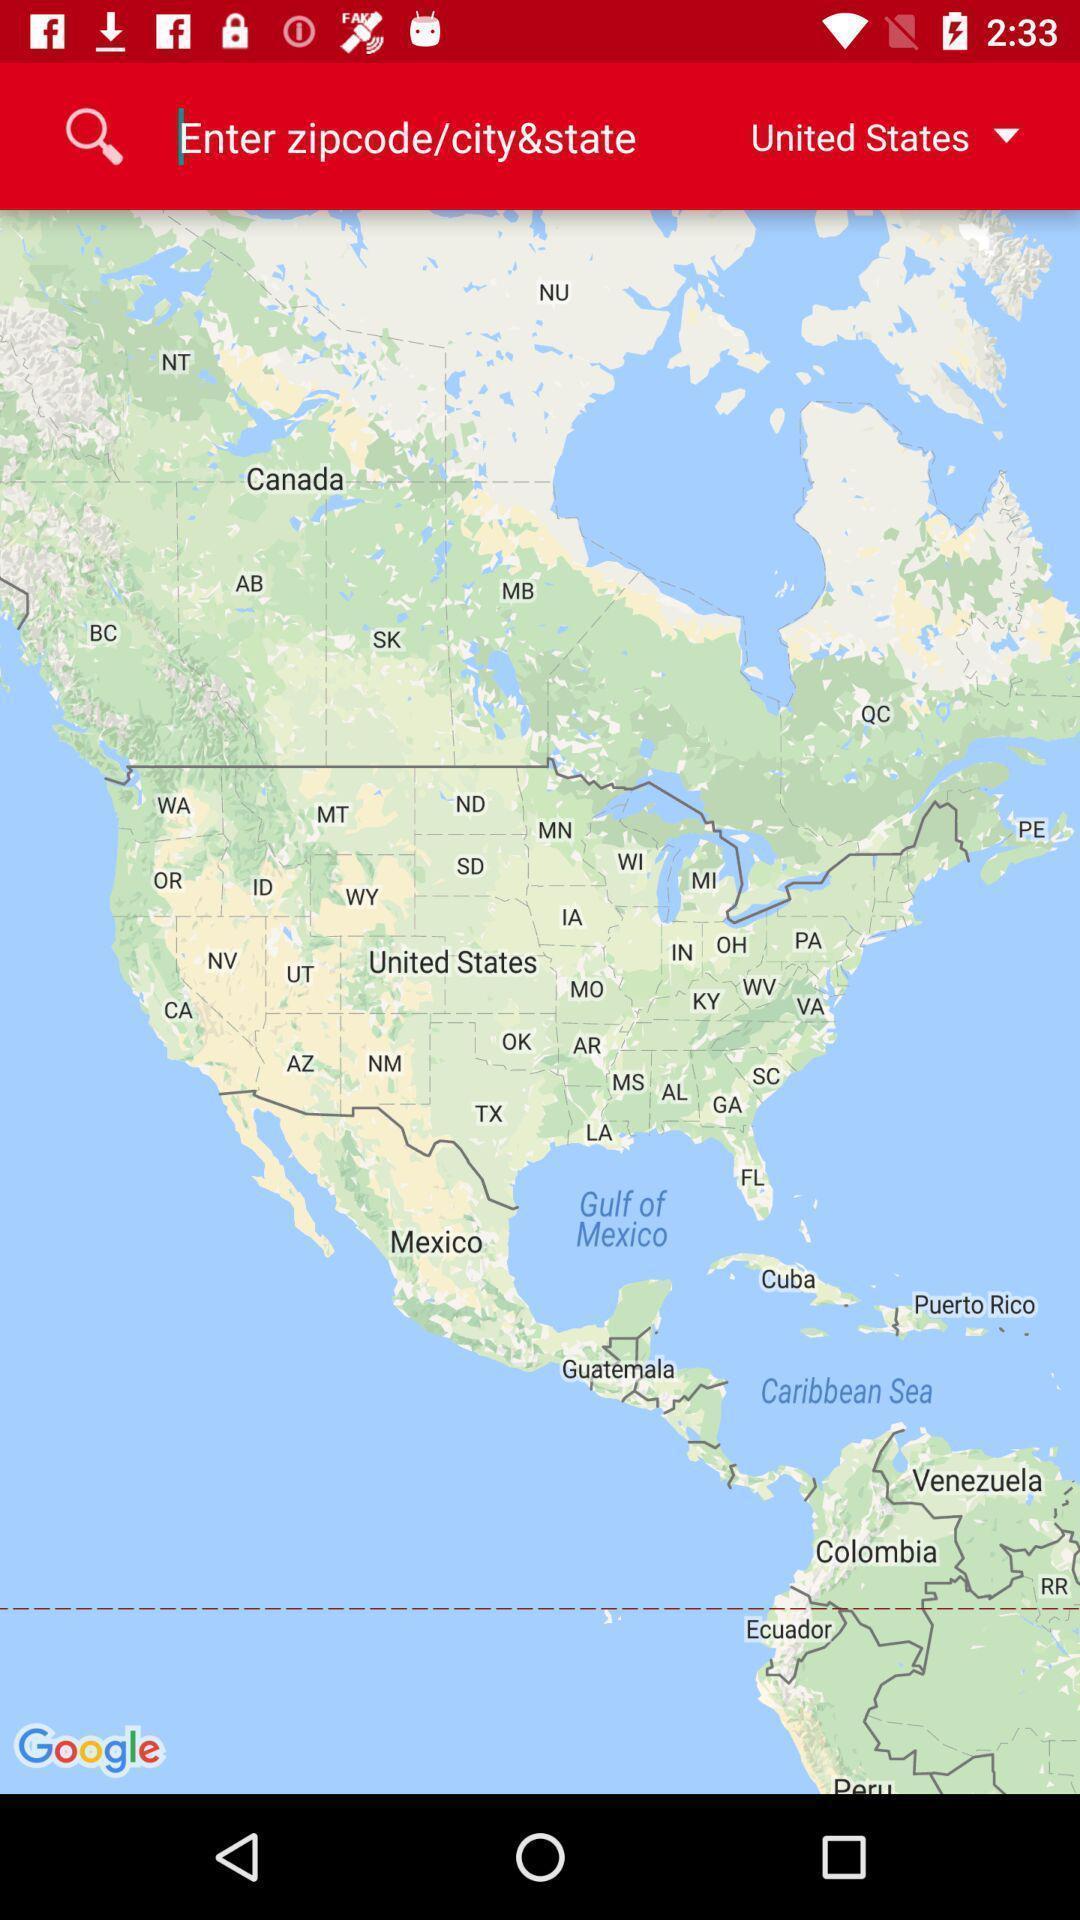What is the overall content of this screenshot? Search page with map. 